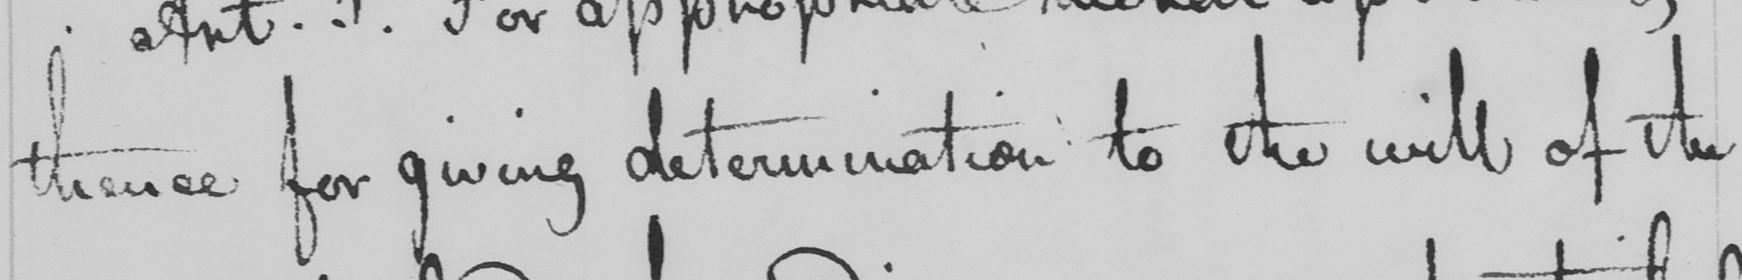Can you tell me what this handwritten text says? thence for giving determination to the will of the 